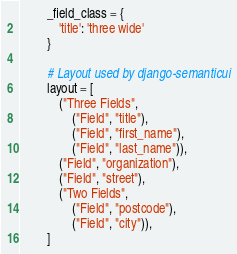<code> <loc_0><loc_0><loc_500><loc_500><_Python_>        _field_class = {
            'title': 'three wide'
        }

        # Layout used by django-semanticui
        layout = [
            ("Three Fields",
                ("Field", "title"),
                ("Field", "first_name"),
                ("Field", "last_name")),
            ("Field", "organization"),
            ("Field", "street"),
            ("Two Fields",
                ("Field", "postcode"),
                ("Field", "city")),
        ]
</code> 